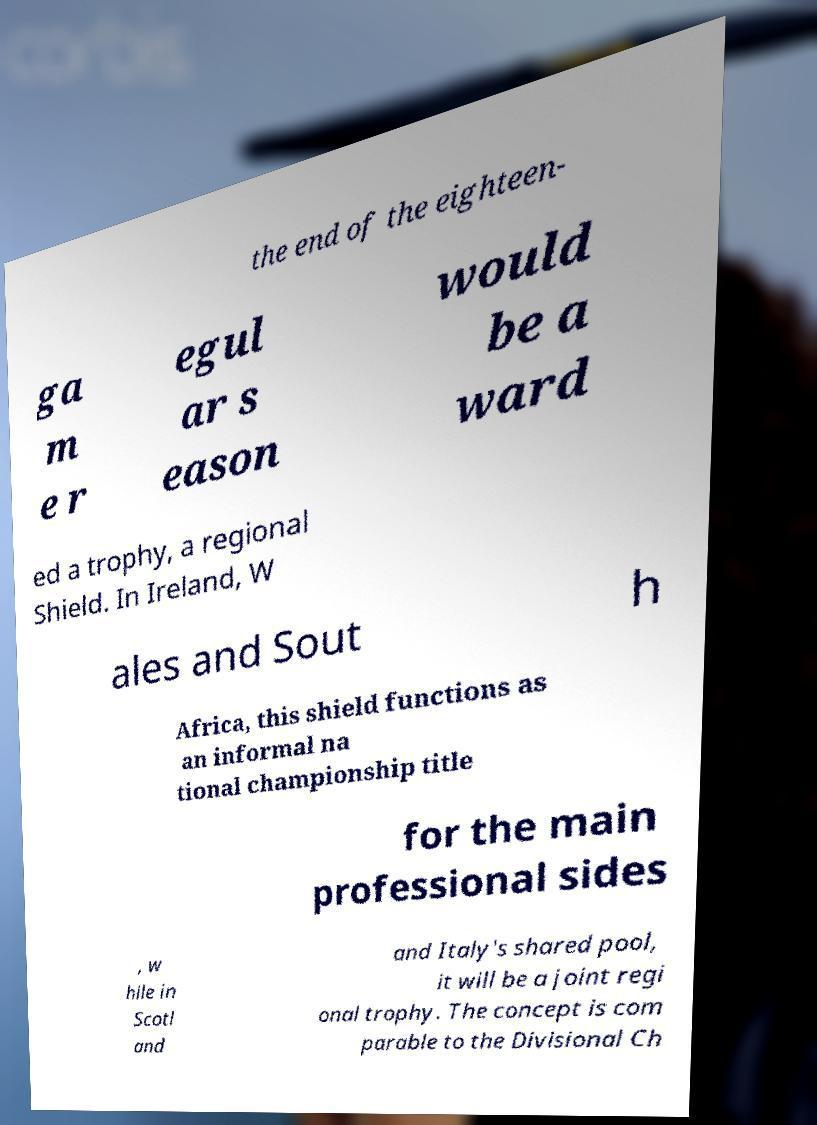I need the written content from this picture converted into text. Can you do that? the end of the eighteen- ga m e r egul ar s eason would be a ward ed a trophy, a regional Shield. In Ireland, W ales and Sout h Africa, this shield functions as an informal na tional championship title for the main professional sides , w hile in Scotl and and Italy's shared pool, it will be a joint regi onal trophy. The concept is com parable to the Divisional Ch 